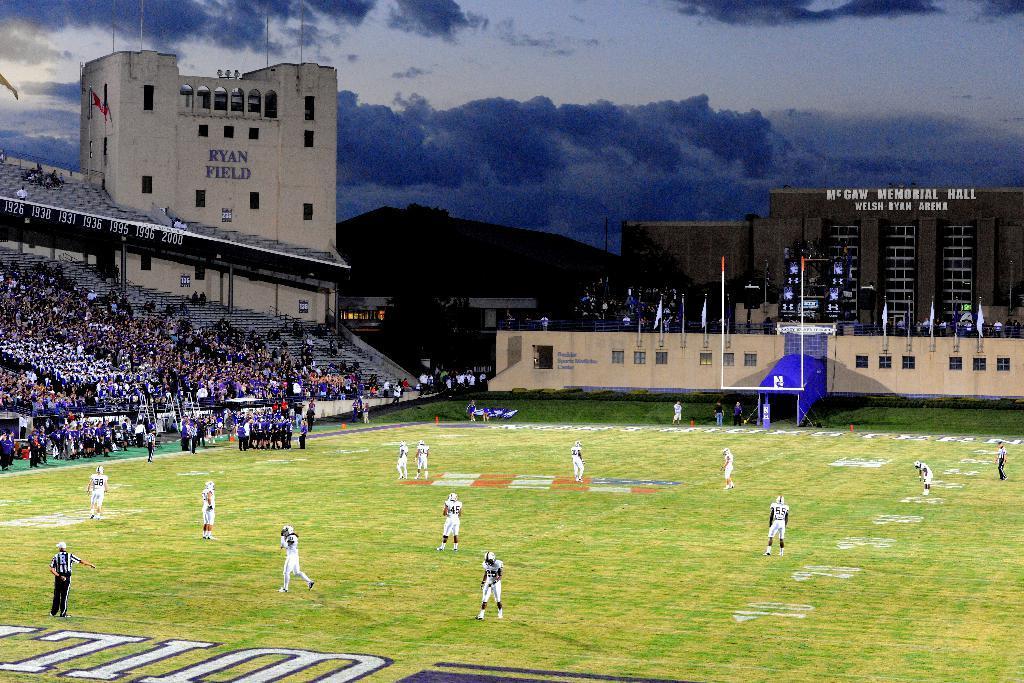Can you describe this image briefly? This picture is taken inside a playground. In this image, we can see a group of people are playing the game. On the left side, we can see a group of people, few people are sitting and few people are standing. In the background, we can see buildings, flags, poles. At the top, we can see a sky which is cloudy, at the bottom, we can see a grass. 